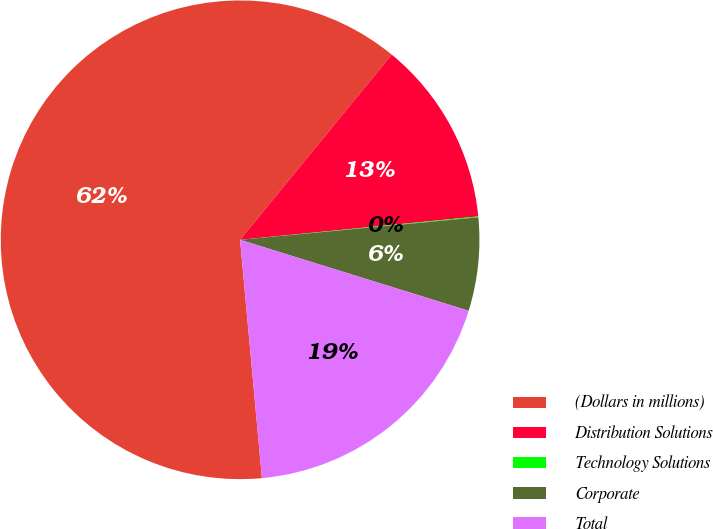Convert chart to OTSL. <chart><loc_0><loc_0><loc_500><loc_500><pie_chart><fcel>(Dollars in millions)<fcel>Distribution Solutions<fcel>Technology Solutions<fcel>Corporate<fcel>Total<nl><fcel>62.37%<fcel>12.52%<fcel>0.06%<fcel>6.29%<fcel>18.75%<nl></chart> 